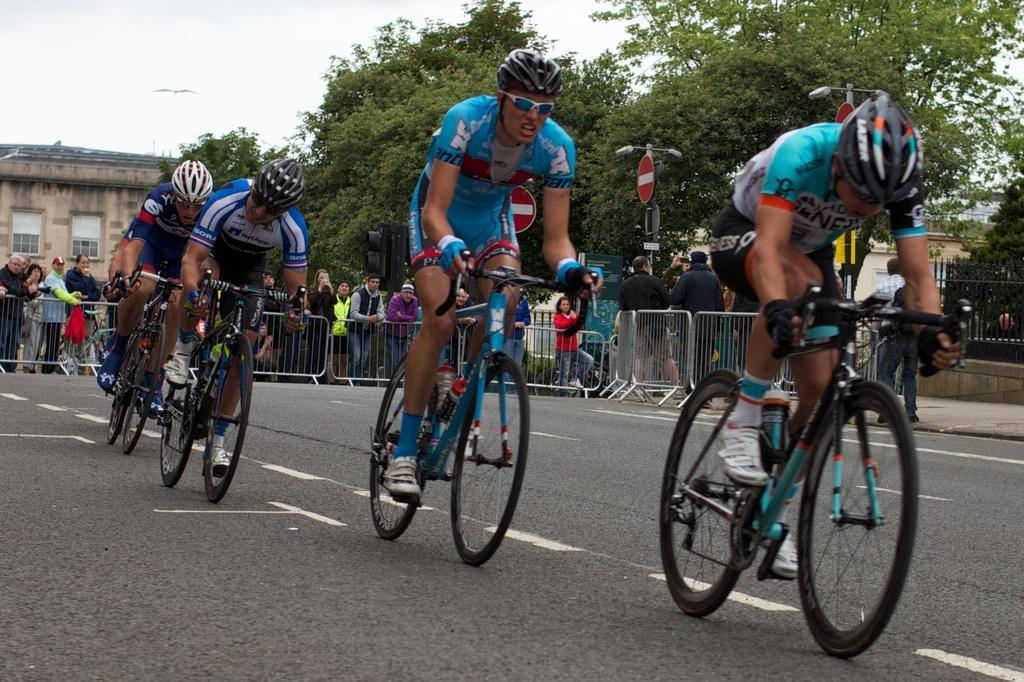What are the persons in the image doing? The persons in the image are riding on bicycles. What safety precaution are the persons taking while riding bicycles? The persons are wearing helmets. What can be seen in the image besides the persons riding bicycles? There is a fence, trees, a building, and the sky visible in the image. What grade of sponge is being used to clean the building in the image? There is no sponge or cleaning activity depicted in the image; it shows persons riding bicycles. How many roses can be seen growing on the trees in the image? There are no roses present on the trees in the image; it features trees without flowers. 